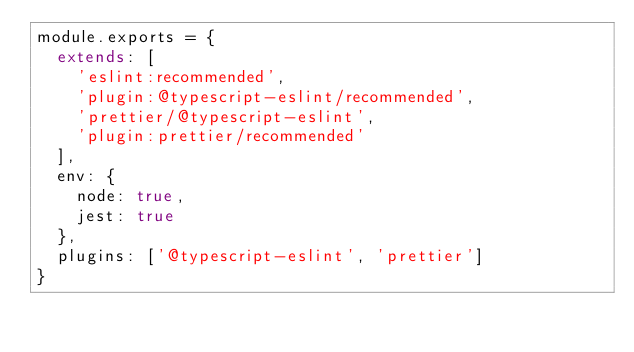Convert code to text. <code><loc_0><loc_0><loc_500><loc_500><_JavaScript_>module.exports = {
  extends: [
    'eslint:recommended',
    'plugin:@typescript-eslint/recommended',
    'prettier/@typescript-eslint',
    'plugin:prettier/recommended'
  ],
  env: {
    node: true,
    jest: true
  },
  plugins: ['@typescript-eslint', 'prettier']
}
</code> 